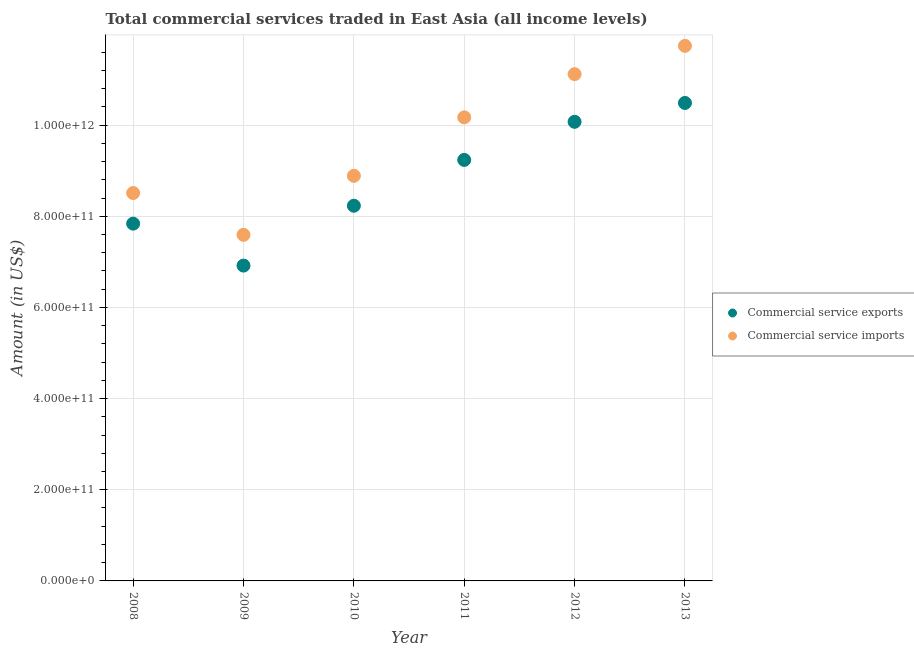How many different coloured dotlines are there?
Your answer should be very brief. 2. Is the number of dotlines equal to the number of legend labels?
Make the answer very short. Yes. What is the amount of commercial service exports in 2011?
Your response must be concise. 9.24e+11. Across all years, what is the maximum amount of commercial service imports?
Your response must be concise. 1.17e+12. Across all years, what is the minimum amount of commercial service exports?
Your answer should be compact. 6.92e+11. What is the total amount of commercial service imports in the graph?
Your answer should be compact. 5.80e+12. What is the difference between the amount of commercial service exports in 2010 and that in 2011?
Provide a short and direct response. -1.01e+11. What is the difference between the amount of commercial service exports in 2010 and the amount of commercial service imports in 2013?
Ensure brevity in your answer.  -3.51e+11. What is the average amount of commercial service exports per year?
Your answer should be very brief. 8.80e+11. In the year 2008, what is the difference between the amount of commercial service imports and amount of commercial service exports?
Ensure brevity in your answer.  6.71e+1. In how many years, is the amount of commercial service imports greater than 640000000000 US$?
Ensure brevity in your answer.  6. What is the ratio of the amount of commercial service imports in 2009 to that in 2011?
Make the answer very short. 0.75. Is the amount of commercial service imports in 2012 less than that in 2013?
Make the answer very short. Yes. Is the difference between the amount of commercial service imports in 2008 and 2009 greater than the difference between the amount of commercial service exports in 2008 and 2009?
Provide a succinct answer. No. What is the difference between the highest and the second highest amount of commercial service imports?
Provide a short and direct response. 6.21e+1. What is the difference between the highest and the lowest amount of commercial service imports?
Your response must be concise. 4.15e+11. Is the sum of the amount of commercial service imports in 2008 and 2012 greater than the maximum amount of commercial service exports across all years?
Keep it short and to the point. Yes. Does the amount of commercial service exports monotonically increase over the years?
Provide a short and direct response. No. Is the amount of commercial service imports strictly less than the amount of commercial service exports over the years?
Offer a very short reply. No. How many dotlines are there?
Offer a very short reply. 2. How many years are there in the graph?
Give a very brief answer. 6. What is the difference between two consecutive major ticks on the Y-axis?
Provide a succinct answer. 2.00e+11. Are the values on the major ticks of Y-axis written in scientific E-notation?
Give a very brief answer. Yes. Where does the legend appear in the graph?
Offer a very short reply. Center right. How many legend labels are there?
Your response must be concise. 2. How are the legend labels stacked?
Your response must be concise. Vertical. What is the title of the graph?
Ensure brevity in your answer.  Total commercial services traded in East Asia (all income levels). What is the label or title of the X-axis?
Your answer should be compact. Year. What is the Amount (in US$) of Commercial service exports in 2008?
Your response must be concise. 7.84e+11. What is the Amount (in US$) in Commercial service imports in 2008?
Provide a short and direct response. 8.51e+11. What is the Amount (in US$) of Commercial service exports in 2009?
Offer a very short reply. 6.92e+11. What is the Amount (in US$) in Commercial service imports in 2009?
Provide a succinct answer. 7.59e+11. What is the Amount (in US$) of Commercial service exports in 2010?
Provide a short and direct response. 8.23e+11. What is the Amount (in US$) in Commercial service imports in 2010?
Your answer should be very brief. 8.89e+11. What is the Amount (in US$) in Commercial service exports in 2011?
Ensure brevity in your answer.  9.24e+11. What is the Amount (in US$) in Commercial service imports in 2011?
Your answer should be compact. 1.02e+12. What is the Amount (in US$) of Commercial service exports in 2012?
Provide a succinct answer. 1.01e+12. What is the Amount (in US$) of Commercial service imports in 2012?
Provide a short and direct response. 1.11e+12. What is the Amount (in US$) of Commercial service exports in 2013?
Make the answer very short. 1.05e+12. What is the Amount (in US$) in Commercial service imports in 2013?
Give a very brief answer. 1.17e+12. Across all years, what is the maximum Amount (in US$) of Commercial service exports?
Keep it short and to the point. 1.05e+12. Across all years, what is the maximum Amount (in US$) of Commercial service imports?
Your answer should be compact. 1.17e+12. Across all years, what is the minimum Amount (in US$) of Commercial service exports?
Your answer should be compact. 6.92e+11. Across all years, what is the minimum Amount (in US$) in Commercial service imports?
Offer a terse response. 7.59e+11. What is the total Amount (in US$) in Commercial service exports in the graph?
Make the answer very short. 5.28e+12. What is the total Amount (in US$) of Commercial service imports in the graph?
Provide a succinct answer. 5.80e+12. What is the difference between the Amount (in US$) in Commercial service exports in 2008 and that in 2009?
Offer a very short reply. 9.21e+1. What is the difference between the Amount (in US$) in Commercial service imports in 2008 and that in 2009?
Ensure brevity in your answer.  9.17e+1. What is the difference between the Amount (in US$) in Commercial service exports in 2008 and that in 2010?
Give a very brief answer. -3.93e+1. What is the difference between the Amount (in US$) of Commercial service imports in 2008 and that in 2010?
Ensure brevity in your answer.  -3.78e+1. What is the difference between the Amount (in US$) of Commercial service exports in 2008 and that in 2011?
Provide a short and direct response. -1.40e+11. What is the difference between the Amount (in US$) of Commercial service imports in 2008 and that in 2011?
Your answer should be very brief. -1.66e+11. What is the difference between the Amount (in US$) in Commercial service exports in 2008 and that in 2012?
Your answer should be very brief. -2.23e+11. What is the difference between the Amount (in US$) in Commercial service imports in 2008 and that in 2012?
Ensure brevity in your answer.  -2.61e+11. What is the difference between the Amount (in US$) of Commercial service exports in 2008 and that in 2013?
Provide a short and direct response. -2.65e+11. What is the difference between the Amount (in US$) of Commercial service imports in 2008 and that in 2013?
Provide a short and direct response. -3.23e+11. What is the difference between the Amount (in US$) in Commercial service exports in 2009 and that in 2010?
Your answer should be compact. -1.31e+11. What is the difference between the Amount (in US$) of Commercial service imports in 2009 and that in 2010?
Provide a short and direct response. -1.29e+11. What is the difference between the Amount (in US$) of Commercial service exports in 2009 and that in 2011?
Provide a succinct answer. -2.32e+11. What is the difference between the Amount (in US$) in Commercial service imports in 2009 and that in 2011?
Keep it short and to the point. -2.58e+11. What is the difference between the Amount (in US$) in Commercial service exports in 2009 and that in 2012?
Offer a very short reply. -3.15e+11. What is the difference between the Amount (in US$) in Commercial service imports in 2009 and that in 2012?
Give a very brief answer. -3.52e+11. What is the difference between the Amount (in US$) of Commercial service exports in 2009 and that in 2013?
Offer a very short reply. -3.57e+11. What is the difference between the Amount (in US$) in Commercial service imports in 2009 and that in 2013?
Give a very brief answer. -4.15e+11. What is the difference between the Amount (in US$) in Commercial service exports in 2010 and that in 2011?
Make the answer very short. -1.01e+11. What is the difference between the Amount (in US$) of Commercial service imports in 2010 and that in 2011?
Ensure brevity in your answer.  -1.28e+11. What is the difference between the Amount (in US$) in Commercial service exports in 2010 and that in 2012?
Give a very brief answer. -1.84e+11. What is the difference between the Amount (in US$) of Commercial service imports in 2010 and that in 2012?
Make the answer very short. -2.23e+11. What is the difference between the Amount (in US$) of Commercial service exports in 2010 and that in 2013?
Offer a very short reply. -2.25e+11. What is the difference between the Amount (in US$) in Commercial service imports in 2010 and that in 2013?
Ensure brevity in your answer.  -2.85e+11. What is the difference between the Amount (in US$) of Commercial service exports in 2011 and that in 2012?
Ensure brevity in your answer.  -8.36e+1. What is the difference between the Amount (in US$) in Commercial service imports in 2011 and that in 2012?
Ensure brevity in your answer.  -9.47e+1. What is the difference between the Amount (in US$) in Commercial service exports in 2011 and that in 2013?
Give a very brief answer. -1.25e+11. What is the difference between the Amount (in US$) in Commercial service imports in 2011 and that in 2013?
Offer a terse response. -1.57e+11. What is the difference between the Amount (in US$) of Commercial service exports in 2012 and that in 2013?
Offer a very short reply. -4.14e+1. What is the difference between the Amount (in US$) in Commercial service imports in 2012 and that in 2013?
Keep it short and to the point. -6.21e+1. What is the difference between the Amount (in US$) of Commercial service exports in 2008 and the Amount (in US$) of Commercial service imports in 2009?
Provide a succinct answer. 2.46e+1. What is the difference between the Amount (in US$) of Commercial service exports in 2008 and the Amount (in US$) of Commercial service imports in 2010?
Give a very brief answer. -1.05e+11. What is the difference between the Amount (in US$) in Commercial service exports in 2008 and the Amount (in US$) in Commercial service imports in 2011?
Offer a terse response. -2.33e+11. What is the difference between the Amount (in US$) of Commercial service exports in 2008 and the Amount (in US$) of Commercial service imports in 2012?
Keep it short and to the point. -3.28e+11. What is the difference between the Amount (in US$) of Commercial service exports in 2008 and the Amount (in US$) of Commercial service imports in 2013?
Offer a terse response. -3.90e+11. What is the difference between the Amount (in US$) of Commercial service exports in 2009 and the Amount (in US$) of Commercial service imports in 2010?
Provide a short and direct response. -1.97e+11. What is the difference between the Amount (in US$) of Commercial service exports in 2009 and the Amount (in US$) of Commercial service imports in 2011?
Your answer should be very brief. -3.25e+11. What is the difference between the Amount (in US$) in Commercial service exports in 2009 and the Amount (in US$) in Commercial service imports in 2012?
Provide a succinct answer. -4.20e+11. What is the difference between the Amount (in US$) of Commercial service exports in 2009 and the Amount (in US$) of Commercial service imports in 2013?
Ensure brevity in your answer.  -4.82e+11. What is the difference between the Amount (in US$) of Commercial service exports in 2010 and the Amount (in US$) of Commercial service imports in 2011?
Keep it short and to the point. -1.94e+11. What is the difference between the Amount (in US$) of Commercial service exports in 2010 and the Amount (in US$) of Commercial service imports in 2012?
Your answer should be compact. -2.89e+11. What is the difference between the Amount (in US$) of Commercial service exports in 2010 and the Amount (in US$) of Commercial service imports in 2013?
Ensure brevity in your answer.  -3.51e+11. What is the difference between the Amount (in US$) of Commercial service exports in 2011 and the Amount (in US$) of Commercial service imports in 2012?
Make the answer very short. -1.88e+11. What is the difference between the Amount (in US$) in Commercial service exports in 2011 and the Amount (in US$) in Commercial service imports in 2013?
Offer a very short reply. -2.50e+11. What is the difference between the Amount (in US$) in Commercial service exports in 2012 and the Amount (in US$) in Commercial service imports in 2013?
Give a very brief answer. -1.67e+11. What is the average Amount (in US$) of Commercial service exports per year?
Your answer should be very brief. 8.80e+11. What is the average Amount (in US$) in Commercial service imports per year?
Keep it short and to the point. 9.67e+11. In the year 2008, what is the difference between the Amount (in US$) in Commercial service exports and Amount (in US$) in Commercial service imports?
Your answer should be compact. -6.71e+1. In the year 2009, what is the difference between the Amount (in US$) of Commercial service exports and Amount (in US$) of Commercial service imports?
Your response must be concise. -6.75e+1. In the year 2010, what is the difference between the Amount (in US$) in Commercial service exports and Amount (in US$) in Commercial service imports?
Make the answer very short. -6.56e+1. In the year 2011, what is the difference between the Amount (in US$) in Commercial service exports and Amount (in US$) in Commercial service imports?
Your answer should be compact. -9.34e+1. In the year 2012, what is the difference between the Amount (in US$) in Commercial service exports and Amount (in US$) in Commercial service imports?
Your answer should be compact. -1.05e+11. In the year 2013, what is the difference between the Amount (in US$) of Commercial service exports and Amount (in US$) of Commercial service imports?
Make the answer very short. -1.25e+11. What is the ratio of the Amount (in US$) of Commercial service exports in 2008 to that in 2009?
Offer a terse response. 1.13. What is the ratio of the Amount (in US$) of Commercial service imports in 2008 to that in 2009?
Your answer should be very brief. 1.12. What is the ratio of the Amount (in US$) in Commercial service exports in 2008 to that in 2010?
Ensure brevity in your answer.  0.95. What is the ratio of the Amount (in US$) in Commercial service imports in 2008 to that in 2010?
Ensure brevity in your answer.  0.96. What is the ratio of the Amount (in US$) of Commercial service exports in 2008 to that in 2011?
Provide a short and direct response. 0.85. What is the ratio of the Amount (in US$) of Commercial service imports in 2008 to that in 2011?
Your response must be concise. 0.84. What is the ratio of the Amount (in US$) in Commercial service exports in 2008 to that in 2012?
Provide a short and direct response. 0.78. What is the ratio of the Amount (in US$) of Commercial service imports in 2008 to that in 2012?
Keep it short and to the point. 0.77. What is the ratio of the Amount (in US$) of Commercial service exports in 2008 to that in 2013?
Give a very brief answer. 0.75. What is the ratio of the Amount (in US$) of Commercial service imports in 2008 to that in 2013?
Provide a short and direct response. 0.72. What is the ratio of the Amount (in US$) of Commercial service exports in 2009 to that in 2010?
Make the answer very short. 0.84. What is the ratio of the Amount (in US$) in Commercial service imports in 2009 to that in 2010?
Offer a very short reply. 0.85. What is the ratio of the Amount (in US$) of Commercial service exports in 2009 to that in 2011?
Give a very brief answer. 0.75. What is the ratio of the Amount (in US$) of Commercial service imports in 2009 to that in 2011?
Your response must be concise. 0.75. What is the ratio of the Amount (in US$) in Commercial service exports in 2009 to that in 2012?
Offer a terse response. 0.69. What is the ratio of the Amount (in US$) of Commercial service imports in 2009 to that in 2012?
Keep it short and to the point. 0.68. What is the ratio of the Amount (in US$) of Commercial service exports in 2009 to that in 2013?
Offer a very short reply. 0.66. What is the ratio of the Amount (in US$) of Commercial service imports in 2009 to that in 2013?
Give a very brief answer. 0.65. What is the ratio of the Amount (in US$) of Commercial service exports in 2010 to that in 2011?
Offer a terse response. 0.89. What is the ratio of the Amount (in US$) in Commercial service imports in 2010 to that in 2011?
Provide a short and direct response. 0.87. What is the ratio of the Amount (in US$) in Commercial service exports in 2010 to that in 2012?
Your response must be concise. 0.82. What is the ratio of the Amount (in US$) of Commercial service imports in 2010 to that in 2012?
Make the answer very short. 0.8. What is the ratio of the Amount (in US$) in Commercial service exports in 2010 to that in 2013?
Provide a succinct answer. 0.79. What is the ratio of the Amount (in US$) in Commercial service imports in 2010 to that in 2013?
Offer a very short reply. 0.76. What is the ratio of the Amount (in US$) of Commercial service exports in 2011 to that in 2012?
Offer a very short reply. 0.92. What is the ratio of the Amount (in US$) in Commercial service imports in 2011 to that in 2012?
Ensure brevity in your answer.  0.91. What is the ratio of the Amount (in US$) in Commercial service exports in 2011 to that in 2013?
Give a very brief answer. 0.88. What is the ratio of the Amount (in US$) of Commercial service imports in 2011 to that in 2013?
Keep it short and to the point. 0.87. What is the ratio of the Amount (in US$) in Commercial service exports in 2012 to that in 2013?
Offer a terse response. 0.96. What is the ratio of the Amount (in US$) in Commercial service imports in 2012 to that in 2013?
Provide a succinct answer. 0.95. What is the difference between the highest and the second highest Amount (in US$) in Commercial service exports?
Offer a very short reply. 4.14e+1. What is the difference between the highest and the second highest Amount (in US$) of Commercial service imports?
Offer a terse response. 6.21e+1. What is the difference between the highest and the lowest Amount (in US$) of Commercial service exports?
Your response must be concise. 3.57e+11. What is the difference between the highest and the lowest Amount (in US$) in Commercial service imports?
Ensure brevity in your answer.  4.15e+11. 